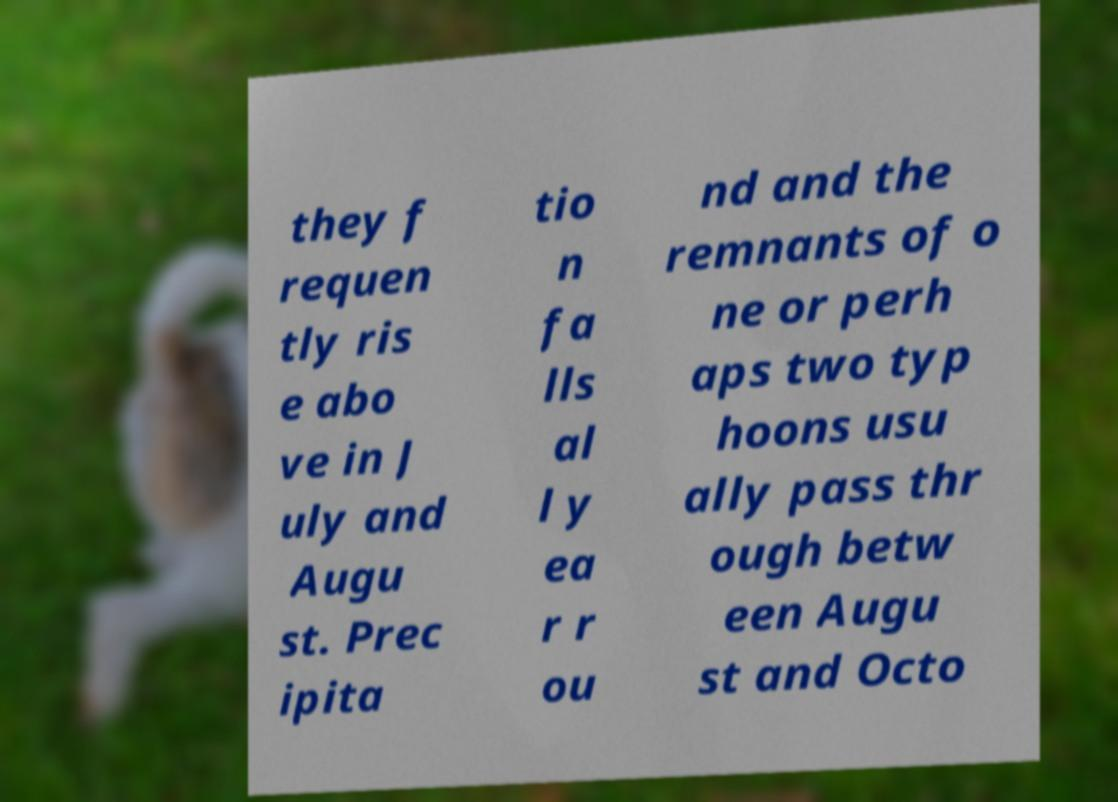Can you accurately transcribe the text from the provided image for me? they f requen tly ris e abo ve in J uly and Augu st. Prec ipita tio n fa lls al l y ea r r ou nd and the remnants of o ne or perh aps two typ hoons usu ally pass thr ough betw een Augu st and Octo 